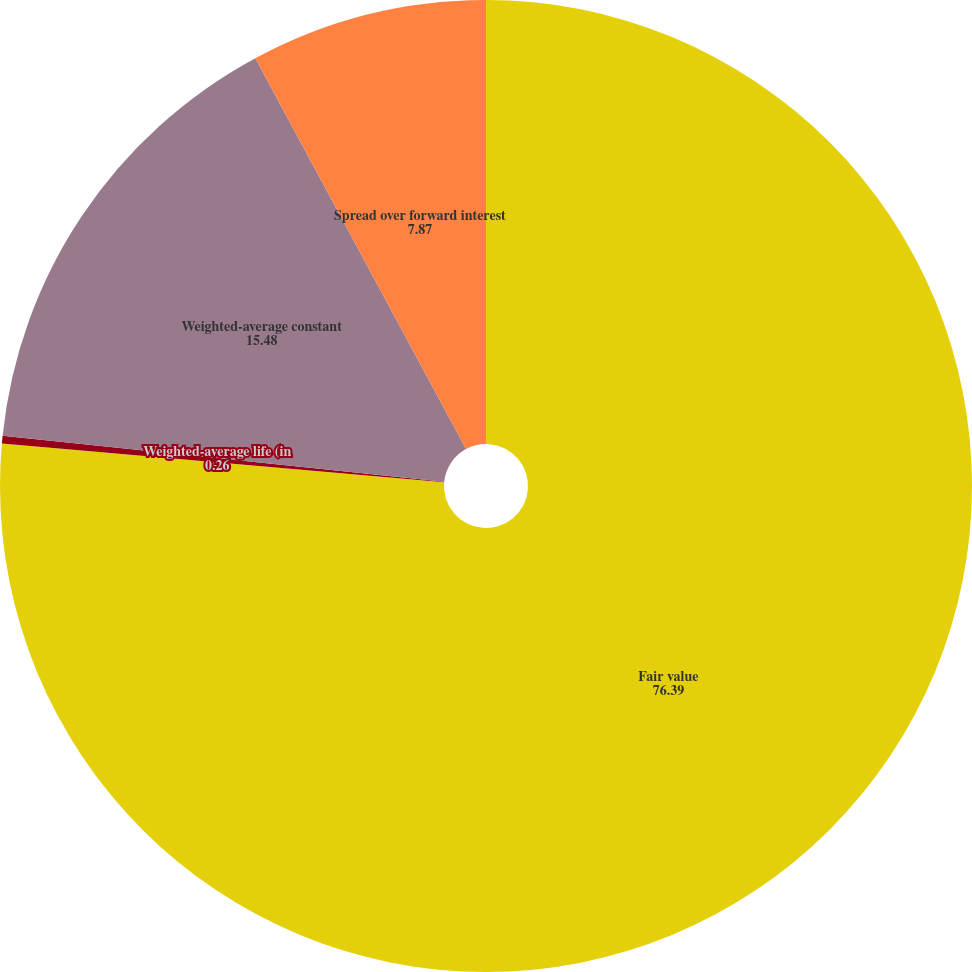<chart> <loc_0><loc_0><loc_500><loc_500><pie_chart><fcel>Fair value<fcel>Weighted-average life (in<fcel>Weighted-average constant<fcel>Spread over forward interest<nl><fcel>76.39%<fcel>0.26%<fcel>15.48%<fcel>7.87%<nl></chart> 